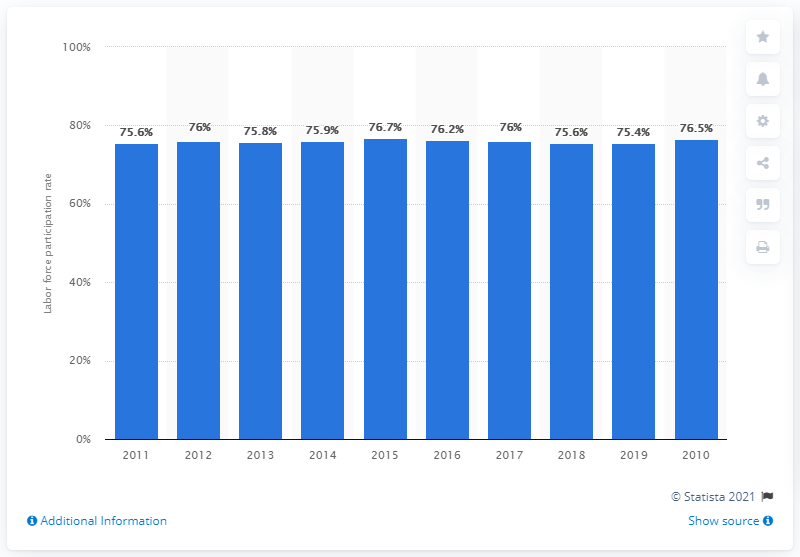Indicate a few pertinent items in this graphic. The labor force participation rate for men in Singapore in 2019 was 75.4%. 